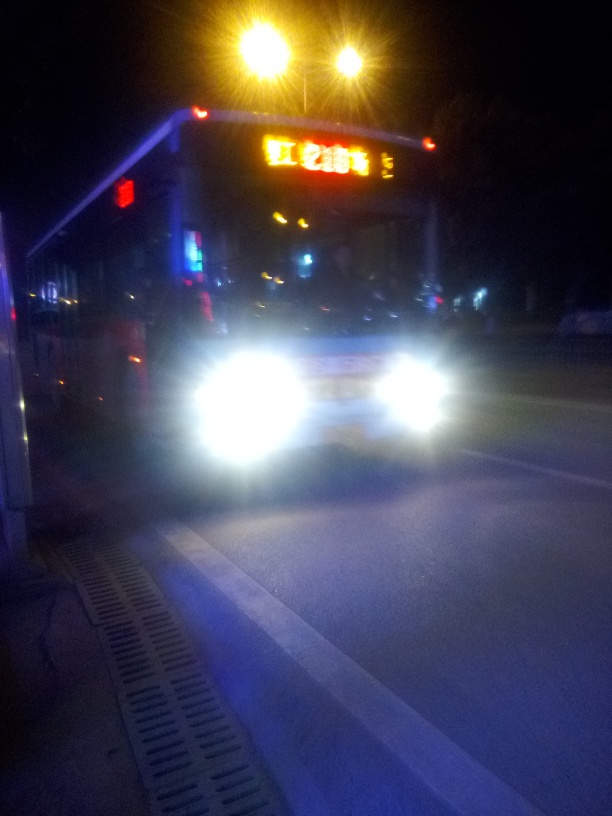What might the brightly lit sign on top of the vehicle indicate? The illuminated sign atop the vehicle typically indicates that this is a service vehicle, such as a taxi or a bus, displaying information pertinent to its service -- likely a route number or destination in the case of a bus, or an 'on duty' light for a taxi. 